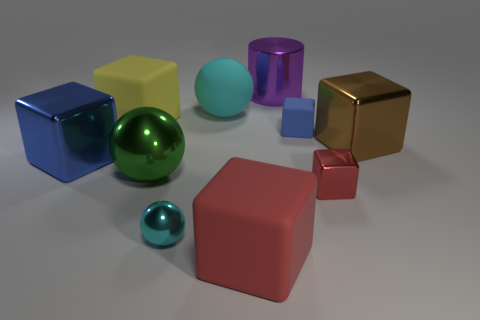Are there the same number of blue matte cubes behind the purple metallic cylinder and cyan rubber blocks?
Offer a terse response. Yes. Is there a large cyan rubber sphere behind the small object that is behind the blue block on the left side of the large purple shiny thing?
Offer a terse response. Yes. What material is the big red cube?
Keep it short and to the point. Rubber. What number of other things are there of the same shape as the purple shiny object?
Your answer should be compact. 0. Do the small matte object and the big blue shiny object have the same shape?
Provide a succinct answer. Yes. How many objects are either small things that are on the right side of the purple cylinder or things that are to the right of the matte ball?
Provide a short and direct response. 5. What number of objects are either big purple metallic objects or big yellow matte spheres?
Your answer should be very brief. 1. There is a big thing that is to the right of the tiny rubber cube; how many large brown blocks are in front of it?
Ensure brevity in your answer.  0. What number of other things are the same size as the brown cube?
Make the answer very short. 6. The block that is the same color as the small rubber thing is what size?
Your response must be concise. Large. 